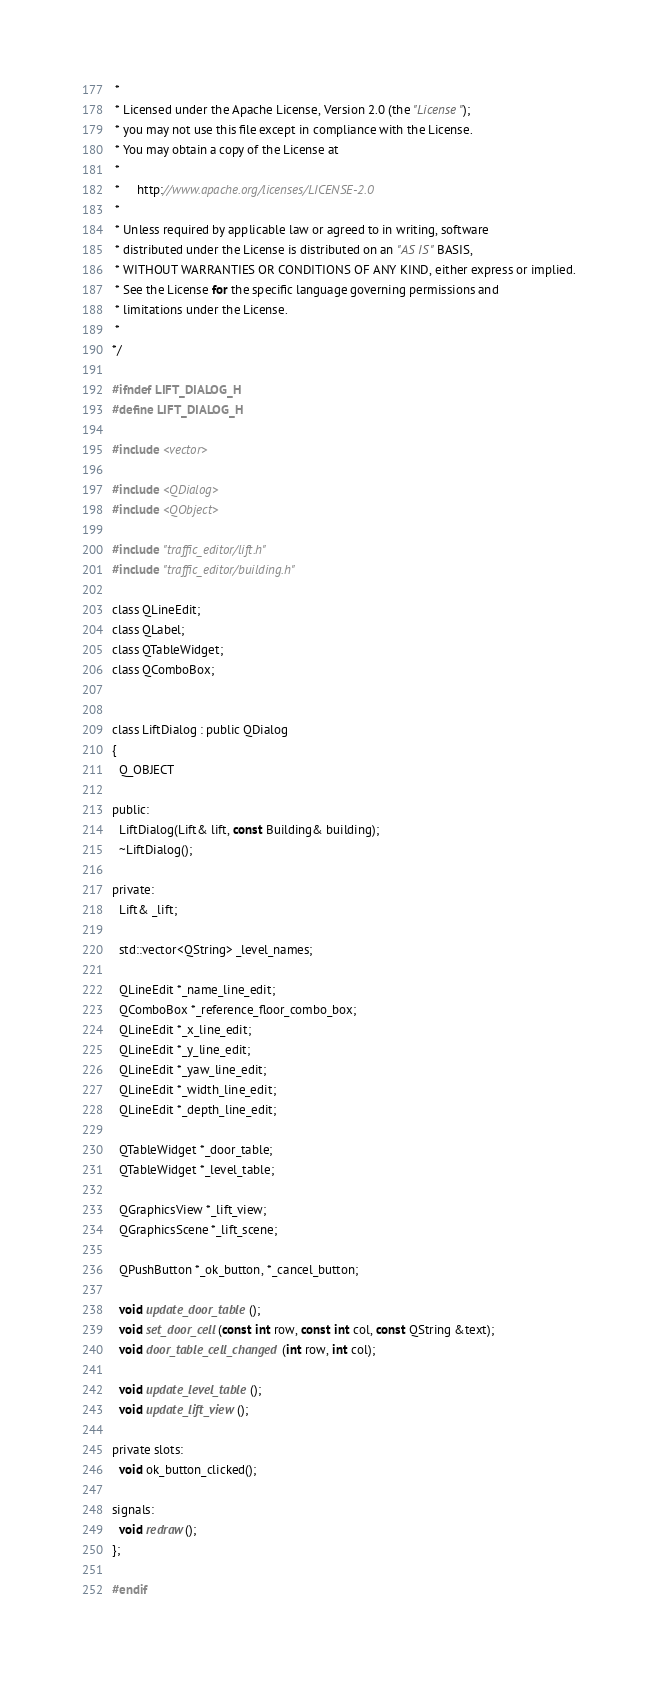Convert code to text. <code><loc_0><loc_0><loc_500><loc_500><_C_> *
 * Licensed under the Apache License, Version 2.0 (the "License");
 * you may not use this file except in compliance with the License.
 * You may obtain a copy of the License at
 *
 *     http://www.apache.org/licenses/LICENSE-2.0
 *
 * Unless required by applicable law or agreed to in writing, software
 * distributed under the License is distributed on an "AS IS" BASIS,
 * WITHOUT WARRANTIES OR CONDITIONS OF ANY KIND, either express or implied.
 * See the License for the specific language governing permissions and
 * limitations under the License.
 *
*/

#ifndef LIFT_DIALOG_H
#define LIFT_DIALOG_H

#include <vector>

#include <QDialog>
#include <QObject>

#include "traffic_editor/lift.h"
#include "traffic_editor/building.h"

class QLineEdit;
class QLabel;
class QTableWidget;
class QComboBox;


class LiftDialog : public QDialog
{
  Q_OBJECT

public:
  LiftDialog(Lift& lift, const Building& building);
  ~LiftDialog();

private:
  Lift& _lift;

  std::vector<QString> _level_names;

  QLineEdit *_name_line_edit;
  QComboBox *_reference_floor_combo_box;
  QLineEdit *_x_line_edit;
  QLineEdit *_y_line_edit;
  QLineEdit *_yaw_line_edit;
  QLineEdit *_width_line_edit;
  QLineEdit *_depth_line_edit;

  QTableWidget *_door_table;
  QTableWidget *_level_table;

  QGraphicsView *_lift_view;
  QGraphicsScene *_lift_scene;

  QPushButton *_ok_button, *_cancel_button;

  void update_door_table();
  void set_door_cell(const int row, const int col, const QString &text);
  void door_table_cell_changed(int row, int col);

  void update_level_table();
  void update_lift_view();

private slots:
  void ok_button_clicked();

signals:
  void redraw();
};

#endif
</code> 